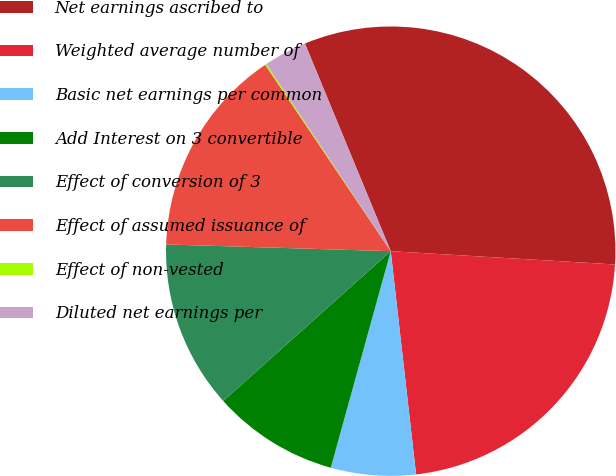Convert chart to OTSL. <chart><loc_0><loc_0><loc_500><loc_500><pie_chart><fcel>Net earnings ascribed to<fcel>Weighted average number of<fcel>Basic net earnings per common<fcel>Add Interest on 3 convertible<fcel>Effect of conversion of 3<fcel>Effect of assumed issuance of<fcel>Effect of non-vested<fcel>Diluted net earnings per<nl><fcel>32.18%<fcel>22.26%<fcel>6.1%<fcel>9.09%<fcel>12.09%<fcel>15.09%<fcel>0.1%<fcel>3.1%<nl></chart> 